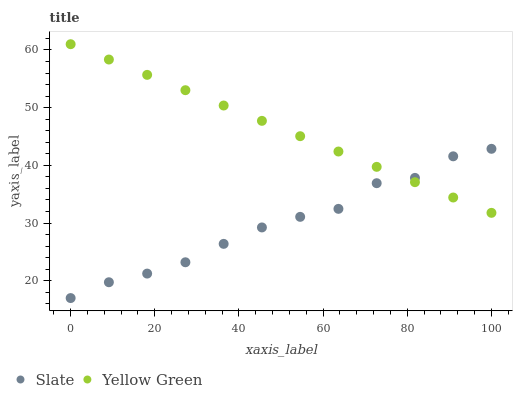Does Slate have the minimum area under the curve?
Answer yes or no. Yes. Does Yellow Green have the maximum area under the curve?
Answer yes or no. Yes. Does Yellow Green have the minimum area under the curve?
Answer yes or no. No. Is Yellow Green the smoothest?
Answer yes or no. Yes. Is Slate the roughest?
Answer yes or no. Yes. Is Yellow Green the roughest?
Answer yes or no. No. Does Slate have the lowest value?
Answer yes or no. Yes. Does Yellow Green have the lowest value?
Answer yes or no. No. Does Yellow Green have the highest value?
Answer yes or no. Yes. Does Yellow Green intersect Slate?
Answer yes or no. Yes. Is Yellow Green less than Slate?
Answer yes or no. No. Is Yellow Green greater than Slate?
Answer yes or no. No. 